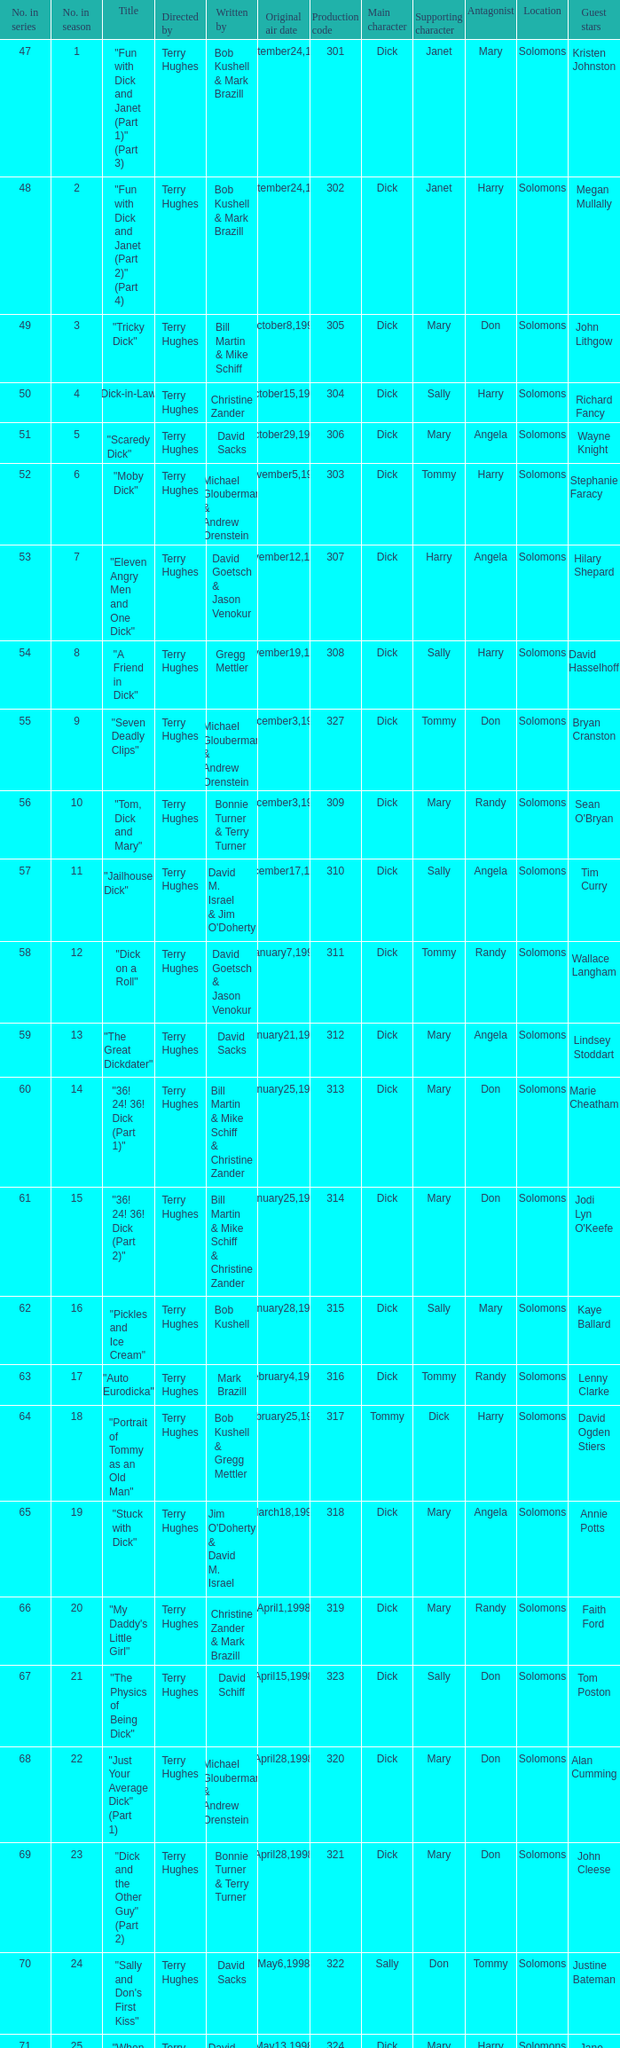What is the title of episode 10? "Tom, Dick and Mary". 